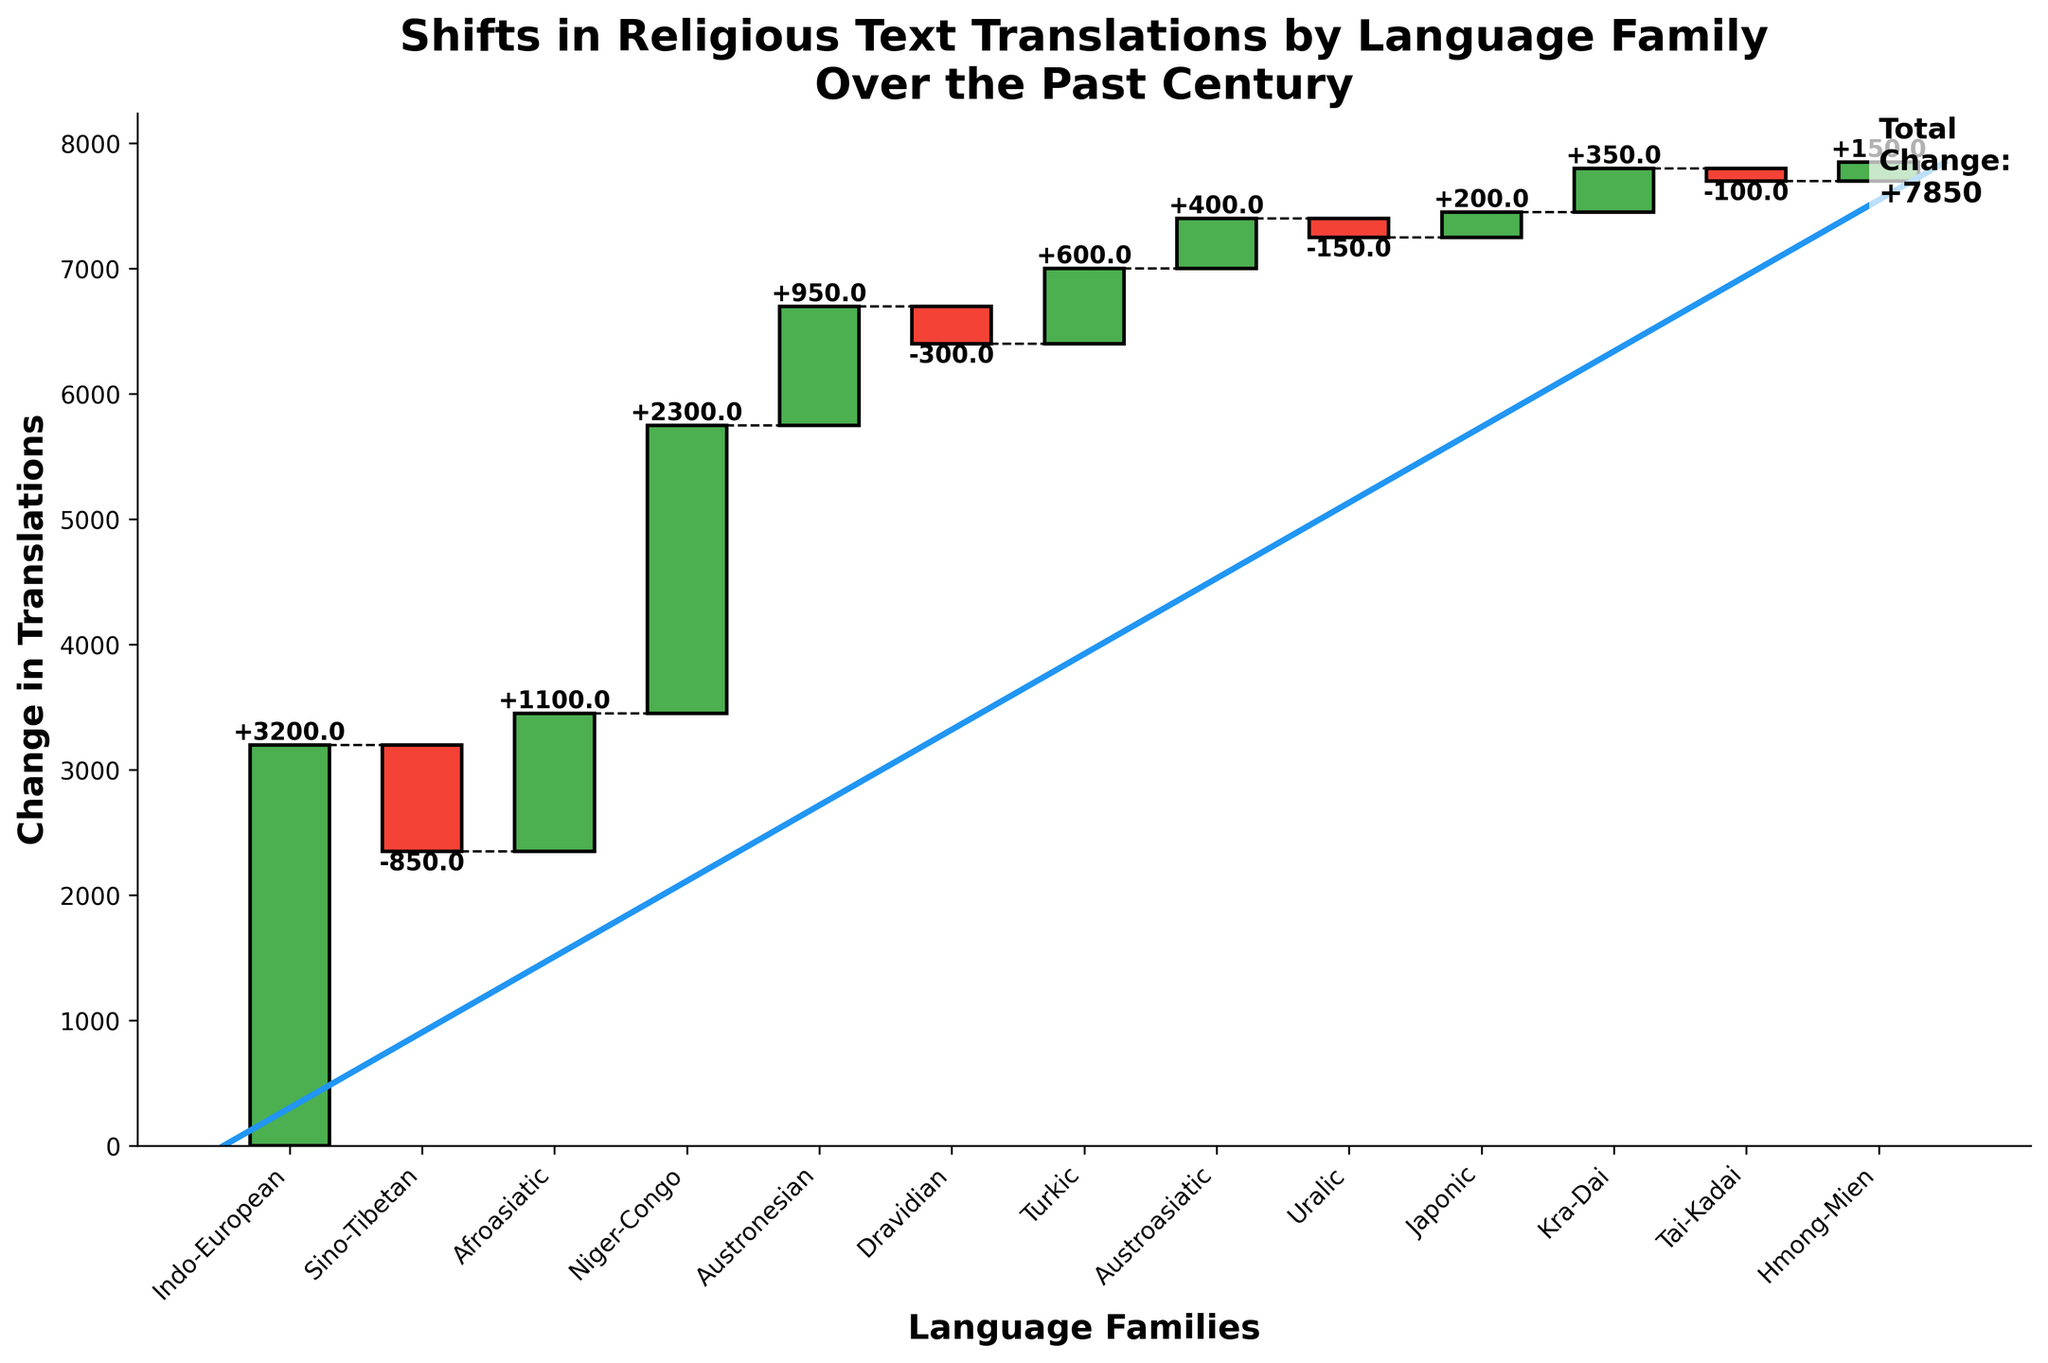Which language family showed the greatest increase in religious text translations? The Indo-European language family showed the greatest increase. This can be determined by looking at the segment with the largest positive value.
Answer: Indo-European What is the total change in religious text translations over the past century? The total change is explicitly labeled on the figure as "Total Change: +7850".
Answer: +7850 How many language families experienced a decrease in translations? Three language families have negative values in their respective segments, indicating a decrease in translations: Sino-Tibetan, Dravidian, and Uralic.
Answer: 3 Which language family has the smallest positive change in translations? By comparing the positive segments, the Japonic language family has the smallest positive change with a value of +200.
Answer: Japonic What is the combined increase in translations for the Indo-European and Niger-Congo language families? Adding the positive values for Indo-European (+3200) and Niger-Congo (+2300) results in a combined increase of 5500.
Answer: 5500 Which language families are represented by the segments colored in green? The positive segments are represented by green color, which include Indo-European, Afroasiatic, Niger-Congo, Austronesian, Turkic, Austroasiatic, Japonic, Kra-Dai, and Hmong-Mien.
Answer: Indo-European, Afroasiatic, Niger-Congo, Austronesian, Turkic, Austroasiatic, Japonic, Kra-Dai, Hmong-Mien Is the Sino-Tibetan language family's change greater than the Turkic language family's change? The Sino-Tibetan language family has a negative change of -850, while the Turkic language family has a positive change of +600. Since -850 is less than +600, the change in Sino-Tibetan is not greater than that of the Turkic language family.
Answer: No What is the cumulative change in translations after including the Afroasiatic language family? The cumulative change in translations after Indo-European and Sino-Tibetan is +2350 (3200 - 850). Adding Afroasiatic's +1100 results in a cumulative change of +3450.
Answer: +3450 Which language family had a shift that nearly balanced out the change in the Dravidian language family? The Austroasiatic language family had a change of +400, which nearly balances the Dravidian's change of -300, though it is not exact.
Answer: Austroasiatic What is the average change in translations for all the language families listed, excluding the total change? Adding all the changes (+3200 - 850 + 1100 + 2300 + 950 - 300 + 600 + 400 - 150 + 200 + 350 -100 + 150) gives +7850. Dividing this by the number of language families (13) results in approximately 603.85.
Answer: 603.85 